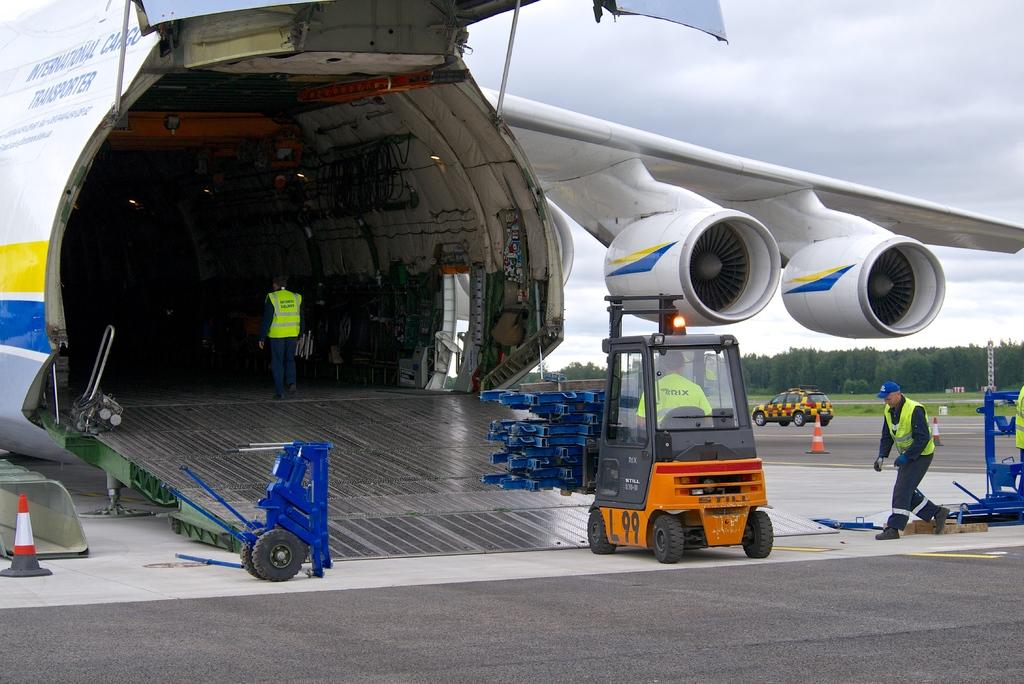<image>
Write a terse but informative summary of the picture. A plane with the word cargo upon it. 